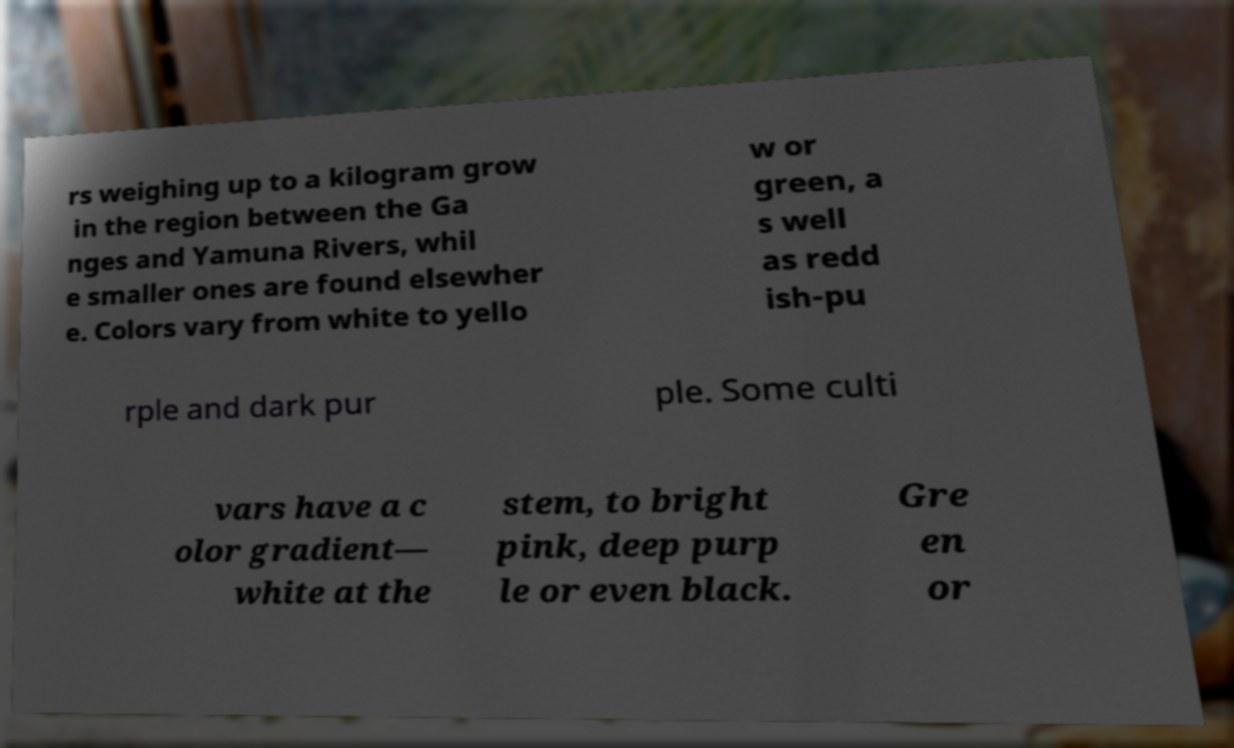For documentation purposes, I need the text within this image transcribed. Could you provide that? rs weighing up to a kilogram grow in the region between the Ga nges and Yamuna Rivers, whil e smaller ones are found elsewher e. Colors vary from white to yello w or green, a s well as redd ish-pu rple and dark pur ple. Some culti vars have a c olor gradient— white at the stem, to bright pink, deep purp le or even black. Gre en or 